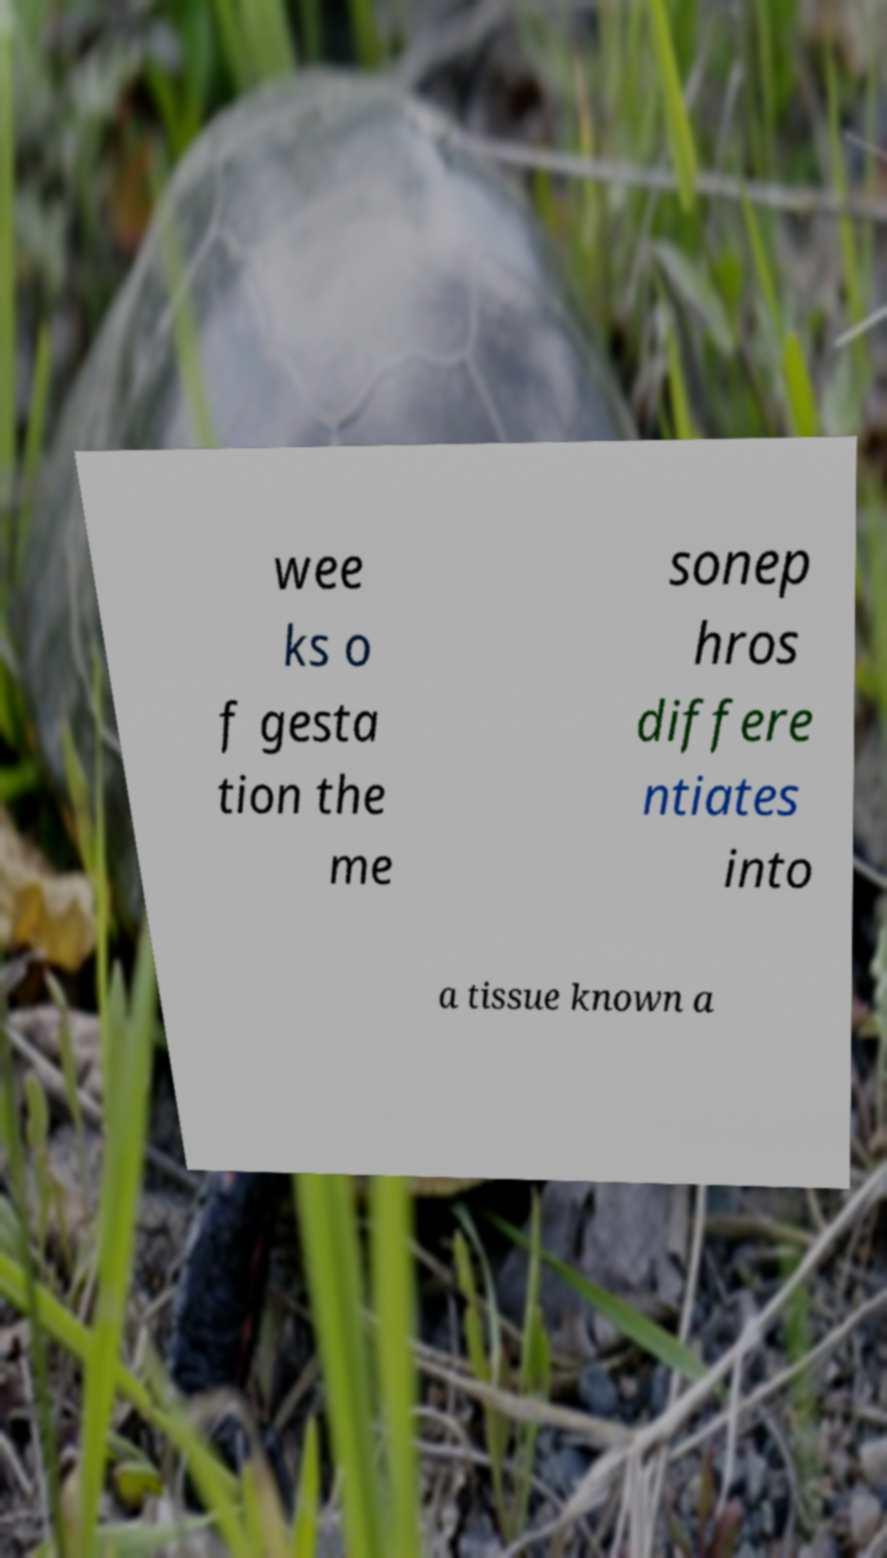Could you extract and type out the text from this image? wee ks o f gesta tion the me sonep hros differe ntiates into a tissue known a 